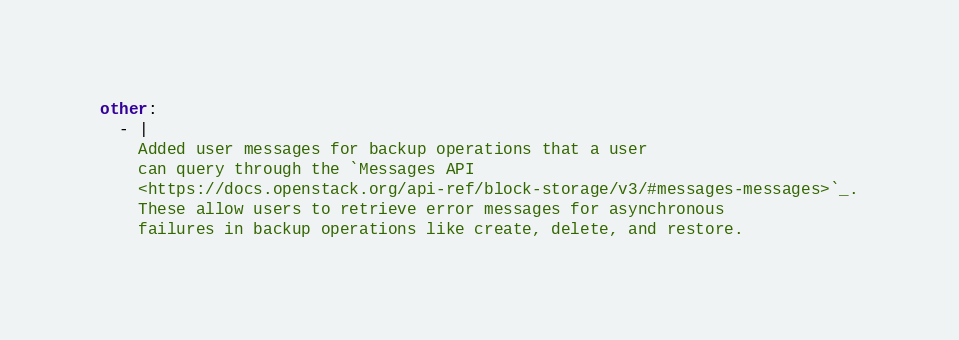<code> <loc_0><loc_0><loc_500><loc_500><_YAML_>other:
  - |
    Added user messages for backup operations that a user
    can query through the `Messages API
    <https://docs.openstack.org/api-ref/block-storage/v3/#messages-messages>`_.
    These allow users to retrieve error messages for asynchronous
    failures in backup operations like create, delete, and restore.</code> 